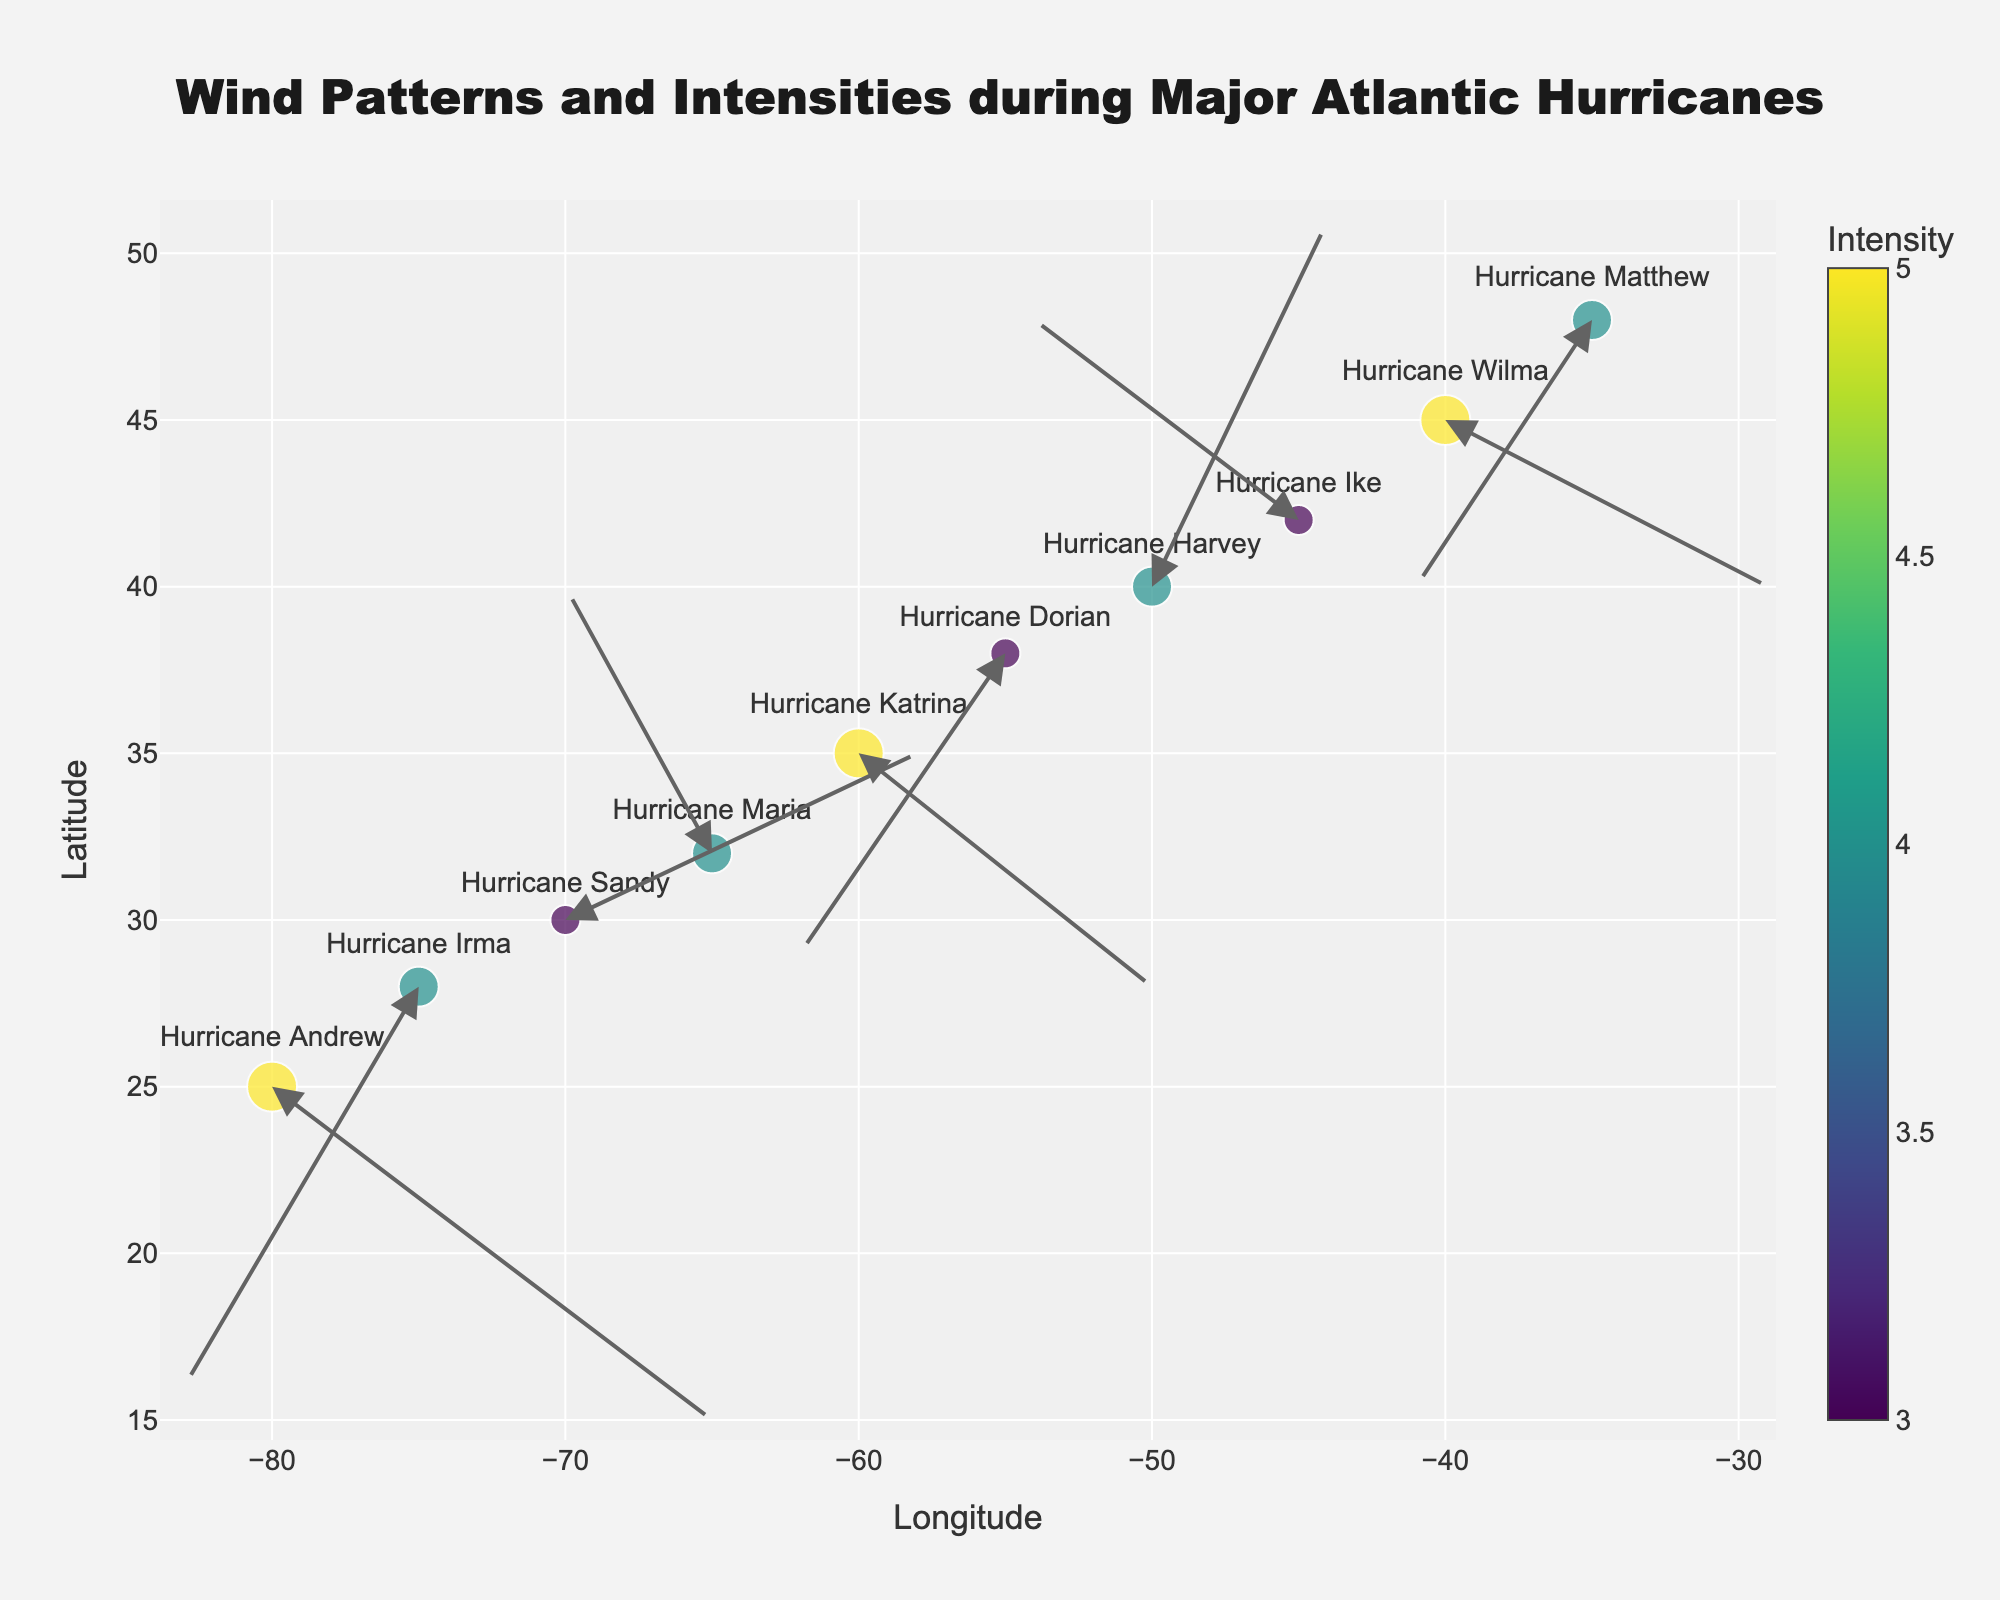What is the title of the plot? The title of the plot is located at the top center of the figure.
Answer: Wind Patterns and Intensities during Major Atlantic Hurricanes How many hurricanes are represented in the plot? Count each marker on the plot representing a hurricane.
Answer: 10 Which hurricane has the highest intensity? Look for the marker with the largest size and the darkest color on the color scale.
Answer: Hurricane Andrew In which direction does Hurricane Irma move? Follow the arrow starting from the marker labeled "Hurricane Irma" to see the direction it points to.
Answer: Southwest Which hurricane occurred furthest north? Look at the y-axis positions of all markers and find the one highest up.
Answer: Hurricane Matthew How does the wind pattern of Hurricane Katrina appear in the plot? Follow the marker labeled "Hurricane Katrina" and observe the direction and length of the arrow starting from it.
Answer: Moves southeast What is the average intensity of the hurricanes represented in the plot? Sum the intensity values of all hurricanes and divide by the number of hurricanes. (5+4+3+4+5+3+4+3+5+4)/10 = 36/10 = 3.6
Answer: 3.6 Which hurricanes have exactly the same intensity levels? Identify hurricanes with the same color on the marker scale and size. Check the color bar if necessary.
Answer: Hurricanes Irma, Maria, Harvey, and Matthew (all intensity 4) Based on the wind patterns, which hurricane moves in nearly the opposite direction to Hurricane Dorian? Compare the direction of arrows for Hurricane Dorian and look for any hurricane with an arrow pointing in almost the opposite direction.
Answer: Hurricane Wilma 